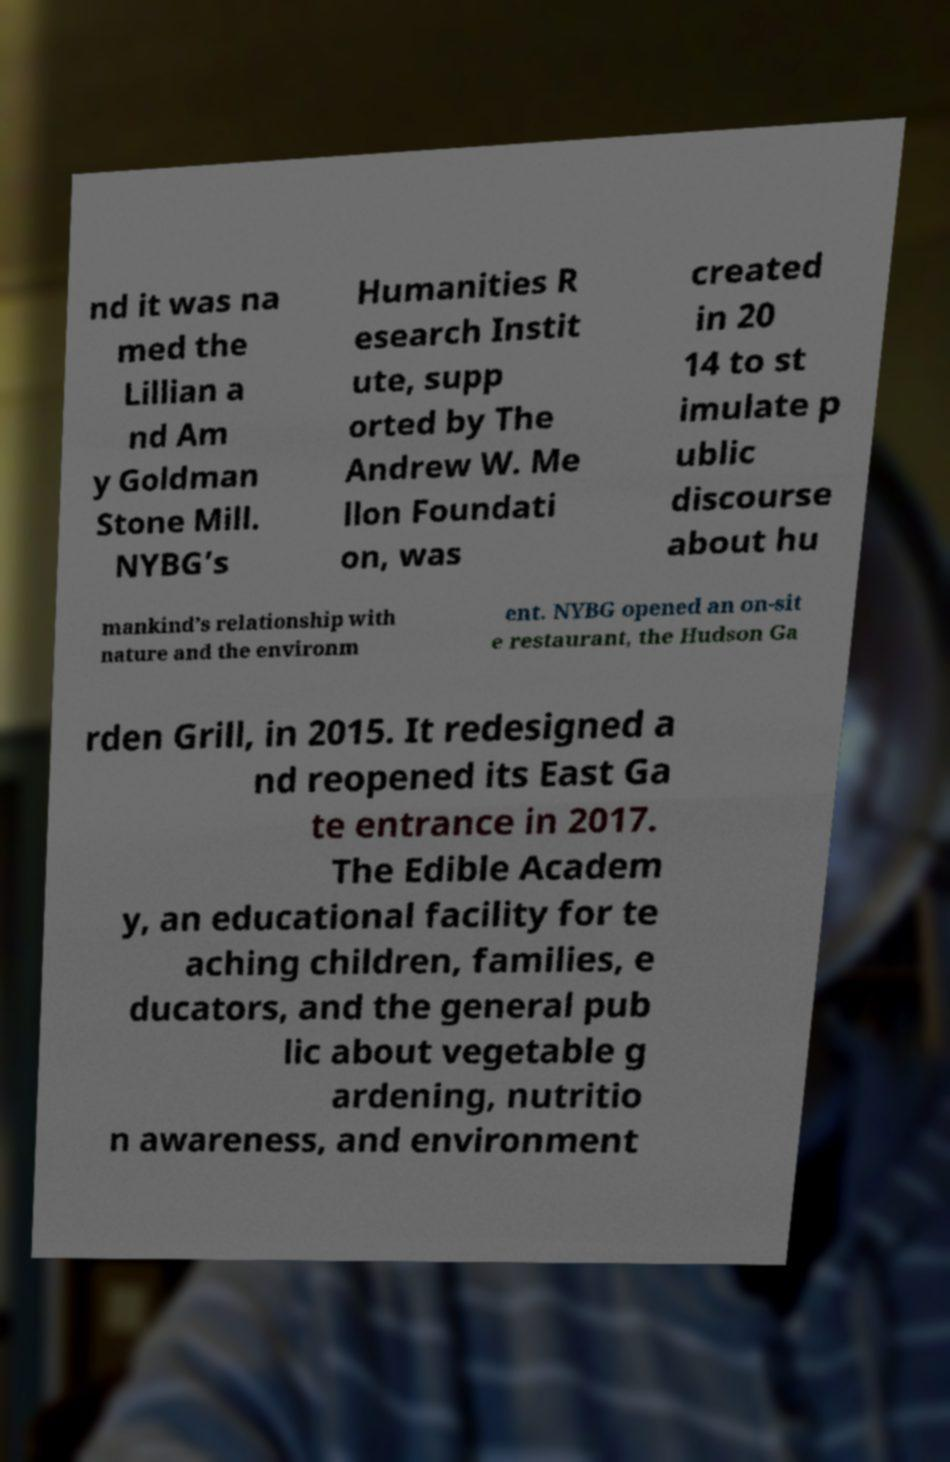Could you assist in decoding the text presented in this image and type it out clearly? nd it was na med the Lillian a nd Am y Goldman Stone Mill. NYBG’s Humanities R esearch Instit ute, supp orted by The Andrew W. Me llon Foundati on, was created in 20 14 to st imulate p ublic discourse about hu mankind’s relationship with nature and the environm ent. NYBG opened an on-sit e restaurant, the Hudson Ga rden Grill, in 2015. It redesigned a nd reopened its East Ga te entrance in 2017. The Edible Academ y, an educational facility for te aching children, families, e ducators, and the general pub lic about vegetable g ardening, nutritio n awareness, and environment 